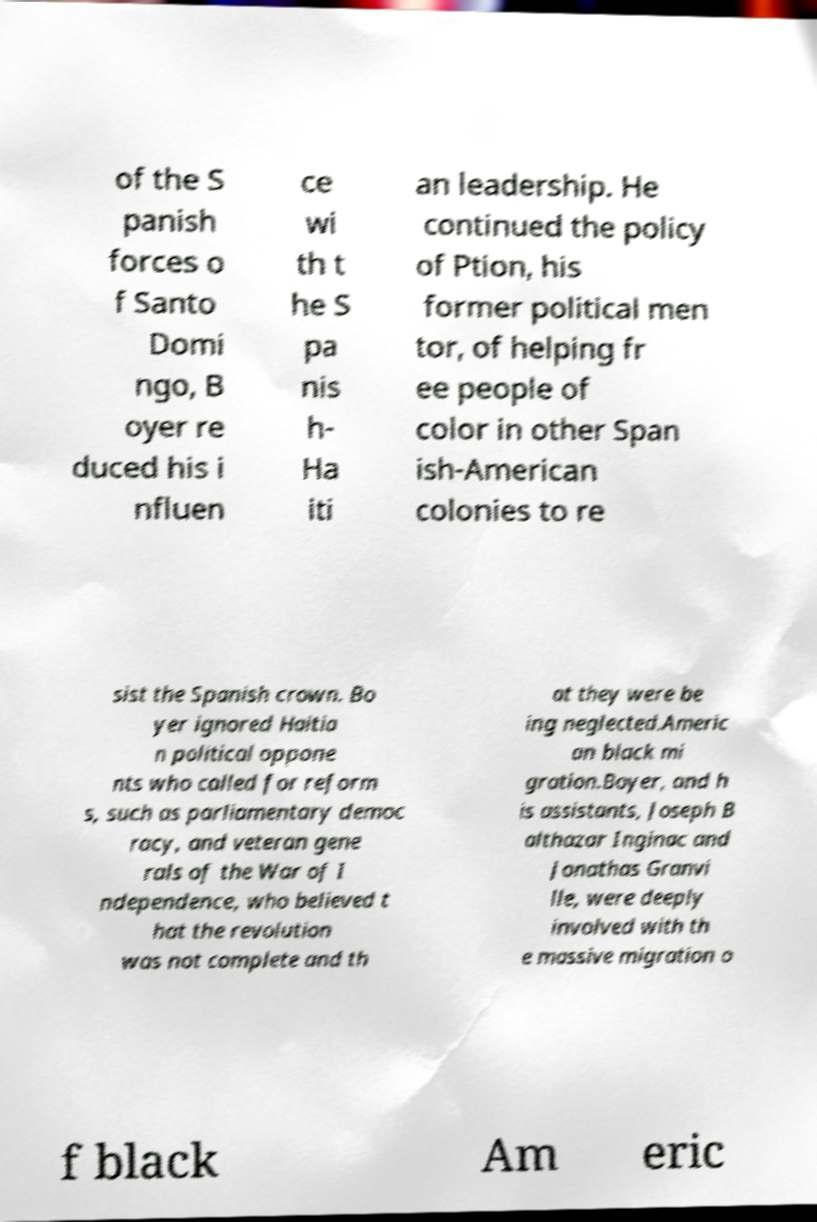I need the written content from this picture converted into text. Can you do that? of the S panish forces o f Santo Domi ngo, B oyer re duced his i nfluen ce wi th t he S pa nis h- Ha iti an leadership. He continued the policy of Ption, his former political men tor, of helping fr ee people of color in other Span ish-American colonies to re sist the Spanish crown. Bo yer ignored Haitia n political oppone nts who called for reform s, such as parliamentary democ racy, and veteran gene rals of the War of I ndependence, who believed t hat the revolution was not complete and th at they were be ing neglected.Americ an black mi gration.Boyer, and h is assistants, Joseph B althazar Inginac and Jonathas Granvi lle, were deeply involved with th e massive migration o f black Am eric 